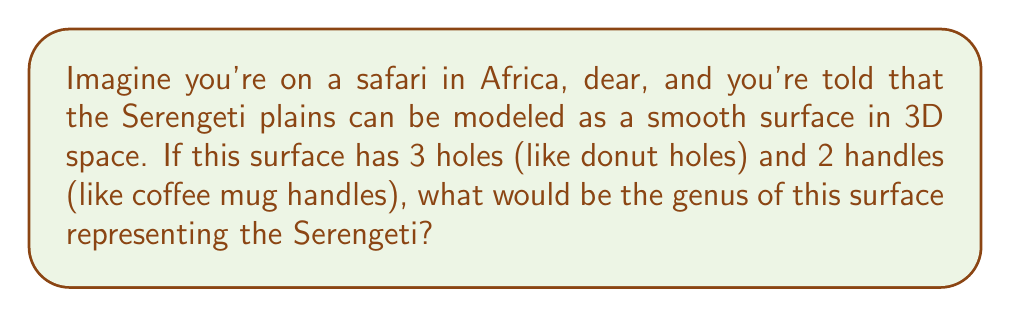What is the answer to this math problem? Let's break this down step-by-step, like we're telling a story about our African adventure:

1. First, we need to understand what genus means. The genus of a surface is like counting how many handles or holes it has. It's a way to describe the shape of the land.

2. In mathematical terms, for a closed orientable surface, the genus $g$ is related to the Euler characteristic $\chi$ by the formula:

   $$\chi = 2 - 2g$$

3. Now, we're told our Serengeti surface has 3 holes and 2 handles. In topology, holes and handles are treated the same way. Each one increases the genus by 1.

4. So, the total number of holes and handles is:
   
   $$3 \text{ holes} + 2 \text{ handles} = 5$$

5. This means the genus of our Serengeti surface is 5.

6. We can double-check using the Euler characteristic formula:
   
   $$\chi = 2 - 2g$$
   $$\chi = 2 - 2(5) = 2 - 10 = -8$$

   This negative Euler characteristic is consistent with a surface of genus 5.

So, just like how the Serengeti is full of diverse landscapes, our mathematical model of it has a rich topological structure!
Answer: 5 